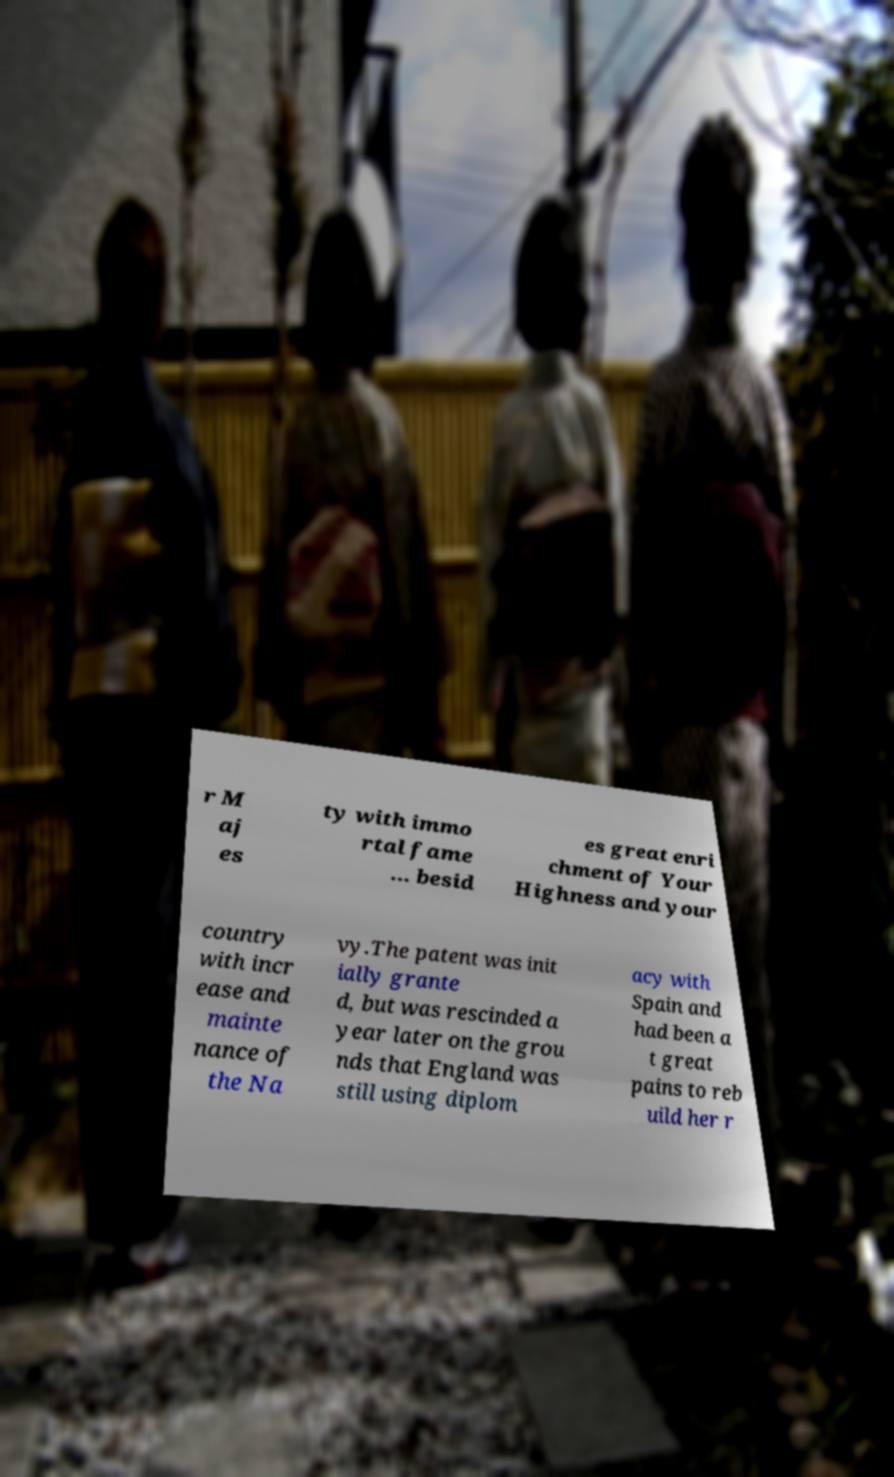Could you assist in decoding the text presented in this image and type it out clearly? r M aj es ty with immo rtal fame ... besid es great enri chment of Your Highness and your country with incr ease and mainte nance of the Na vy.The patent was init ially grante d, but was rescinded a year later on the grou nds that England was still using diplom acy with Spain and had been a t great pains to reb uild her r 